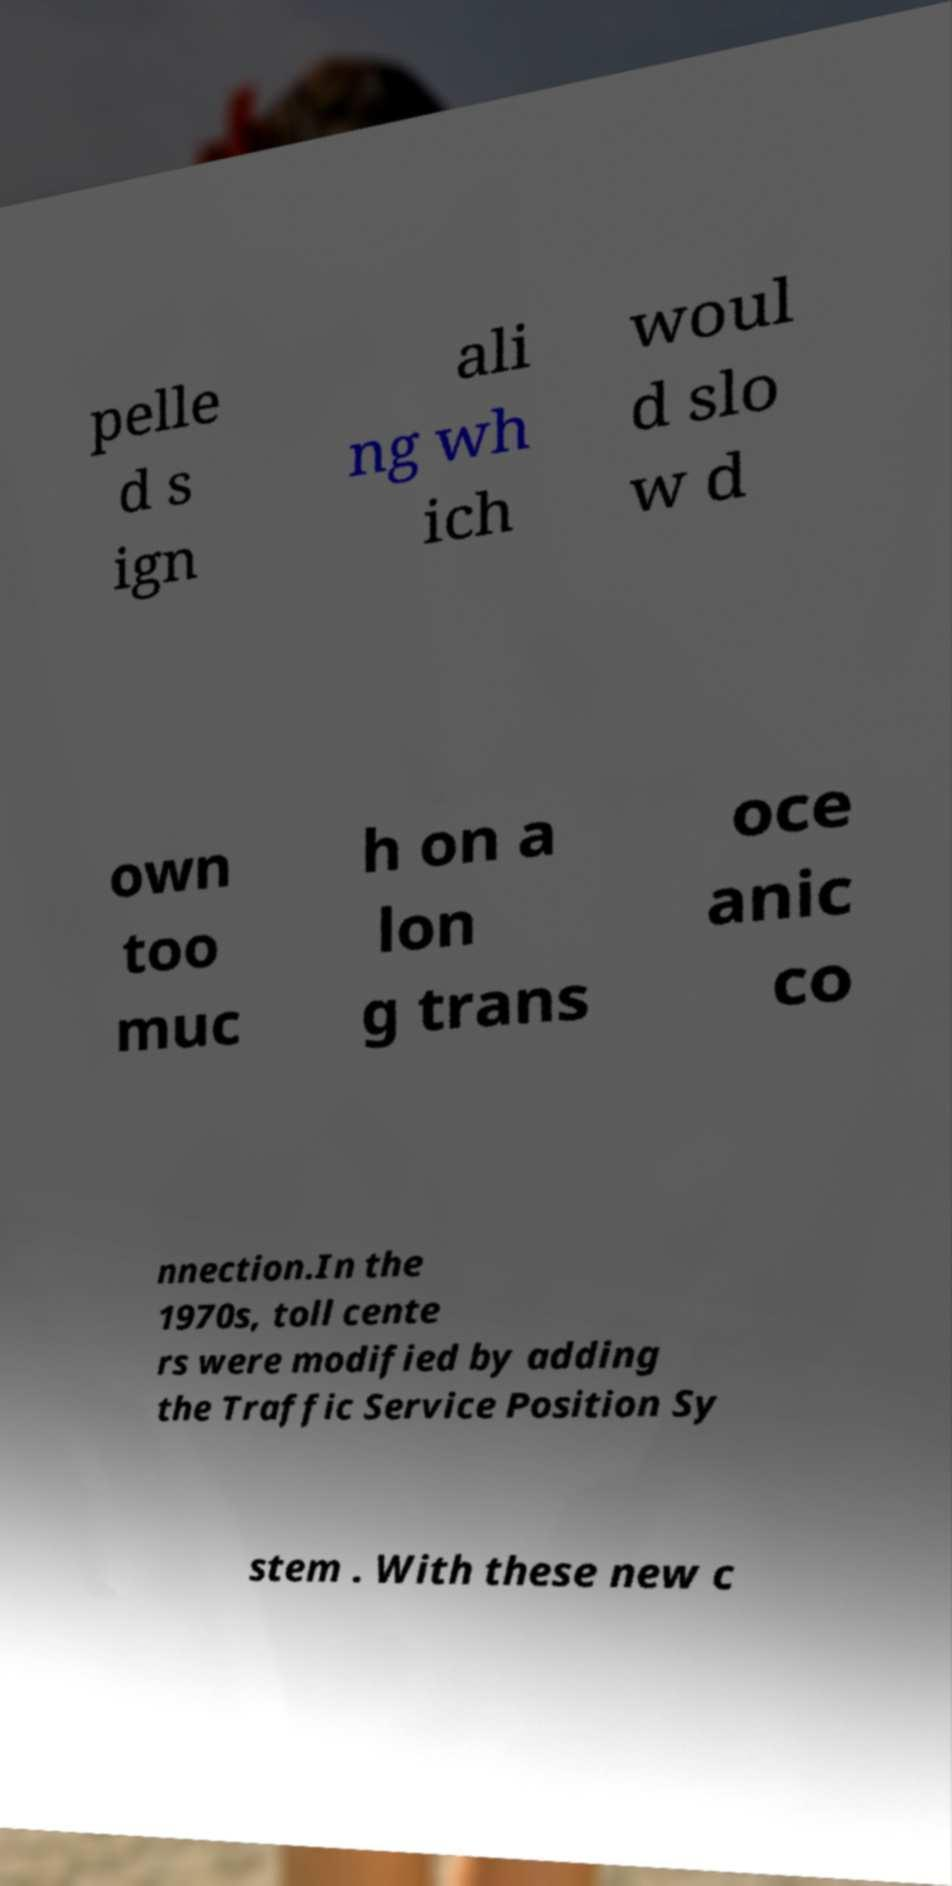Can you read and provide the text displayed in the image?This photo seems to have some interesting text. Can you extract and type it out for me? pelle d s ign ali ng wh ich woul d slo w d own too muc h on a lon g trans oce anic co nnection.In the 1970s, toll cente rs were modified by adding the Traffic Service Position Sy stem . With these new c 